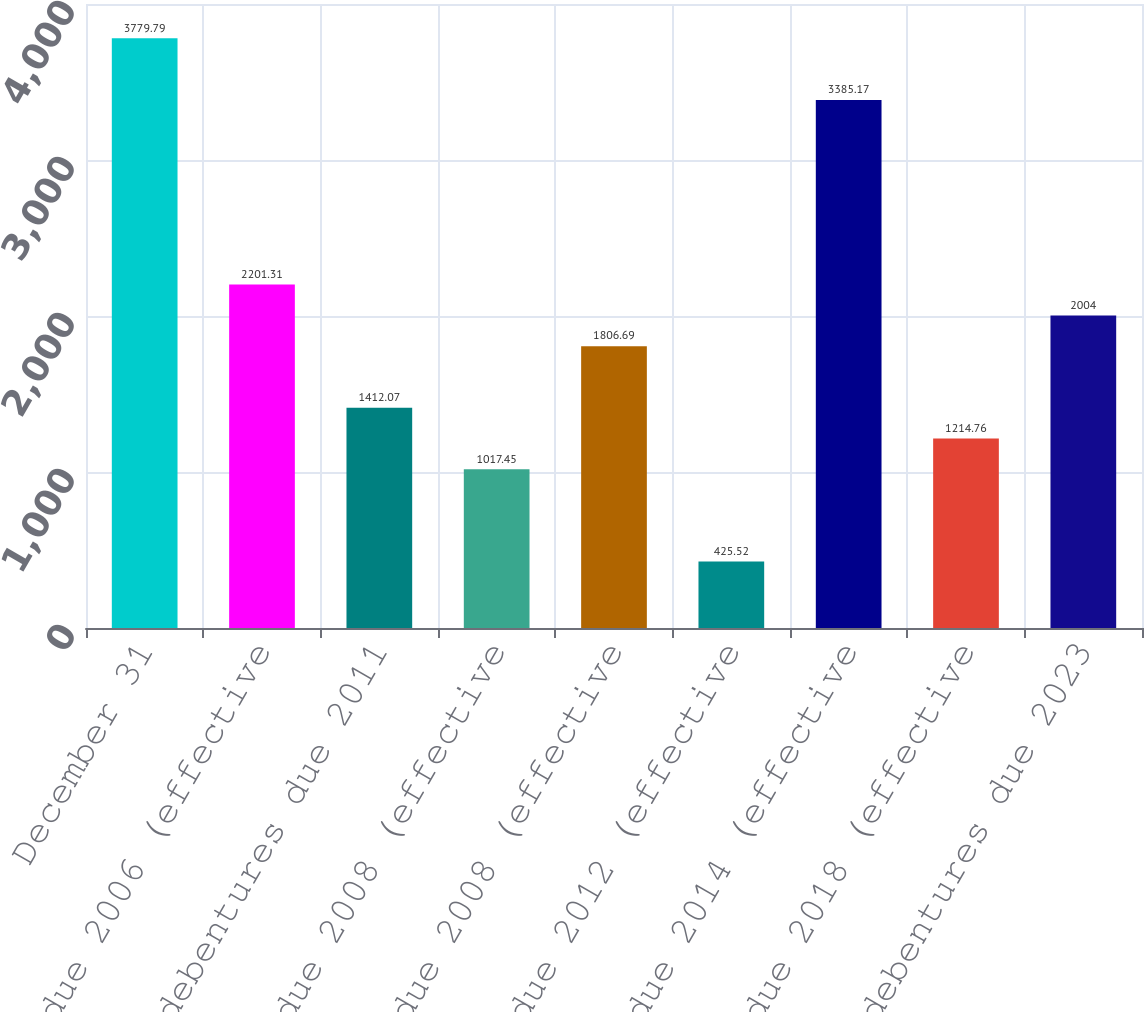Convert chart to OTSL. <chart><loc_0><loc_0><loc_500><loc_500><bar_chart><fcel>December 31<fcel>68 notes due 2006 (effective<fcel>89 debentures due 2011<fcel>65 notes due 2008 (effective<fcel>66 notes due 2008 (effective<fcel>84 notes due 2012 (effective<fcel>59 notes due 2014 (effective<fcel>70 notes due 2018 (effective<fcel>73 debentures due 2023<nl><fcel>3779.79<fcel>2201.31<fcel>1412.07<fcel>1017.45<fcel>1806.69<fcel>425.52<fcel>3385.17<fcel>1214.76<fcel>2004<nl></chart> 